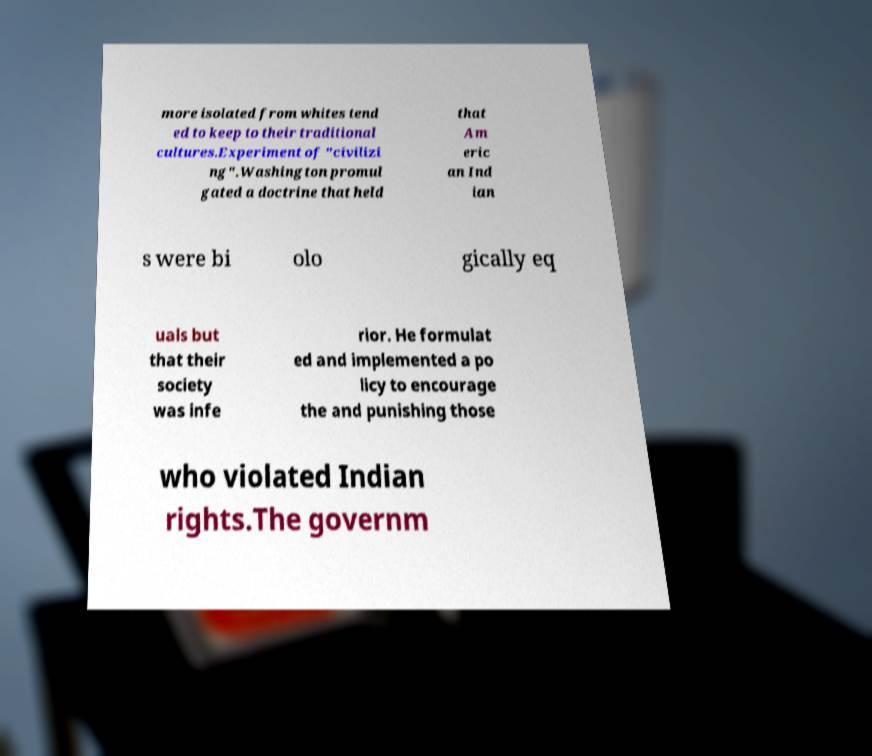Can you accurately transcribe the text from the provided image for me? more isolated from whites tend ed to keep to their traditional cultures.Experiment of "civilizi ng".Washington promul gated a doctrine that held that Am eric an Ind ian s were bi olo gically eq uals but that their society was infe rior. He formulat ed and implemented a po licy to encourage the and punishing those who violated Indian rights.The governm 